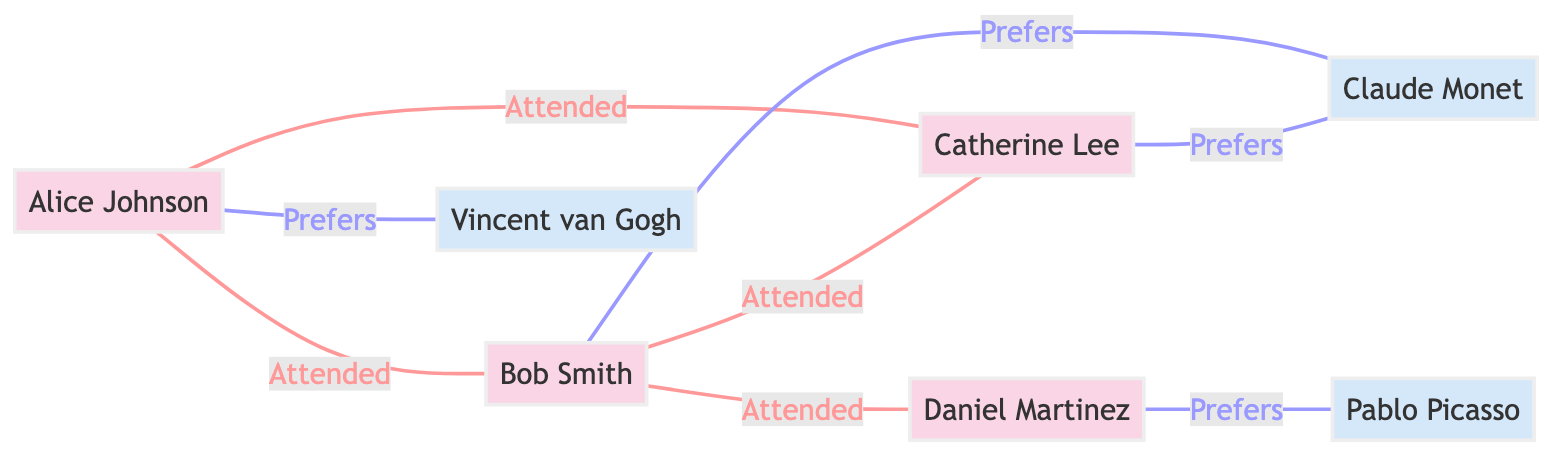What is the total number of gallery visitors in the diagram? The diagram has a total of four nodes representing gallery visitors: Alice Johnson, Bob Smith, Catherine Lee, and Daniel Martinez. Counting these nodes gives us the total number of gallery visitors.
Answer: 4 Who prefers Claude Monet? In the diagram, both Bob Smith and Catherine Lee have edges labeled "Prefers" that point to the node for Claude Monet. This indicates their preference for the artist.
Answer: Bob Smith, Catherine Lee How many events did Daniel Martinez attend? Daniel Martinez is connected to only one other visitor, Bob Smith, in the context of "Attended_Same_Event". Therefore, the only event he attended, as inferred from his connections, is the Cubist Exhibition with Bob Smith.
Answer: 1 Which artist is preferred by Daniel Martinez? The edge connecting Daniel Martinez to Pablo Picasso indicates that he prefers Pablo Picasso as an artist.
Answer: Pablo Picasso What is the relationship between Alice Johnson and Bob Smith? The edge labeled "Attended" directly connects Alice Johnson to Bob Smith, indicating that they attended the same event together, specifically the Impressionist Masterpieces.
Answer: Attended_Same_Event 